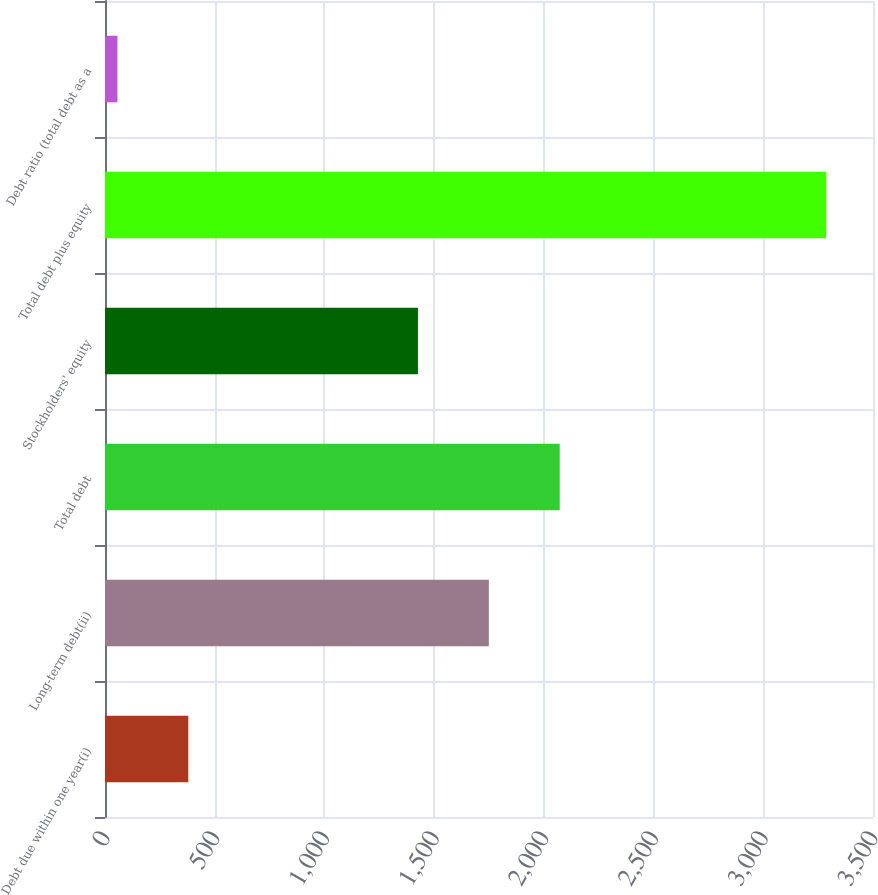Convert chart to OTSL. <chart><loc_0><loc_0><loc_500><loc_500><bar_chart><fcel>Debt due within one year(i)<fcel>Long-term debt(ii)<fcel>Total debt<fcel>Stockholders' equity<fcel>Total debt plus equity<fcel>Debt ratio (total debt as a<nl><fcel>379.62<fcel>1749.22<fcel>2072.24<fcel>1426.2<fcel>3286.8<fcel>56.6<nl></chart> 